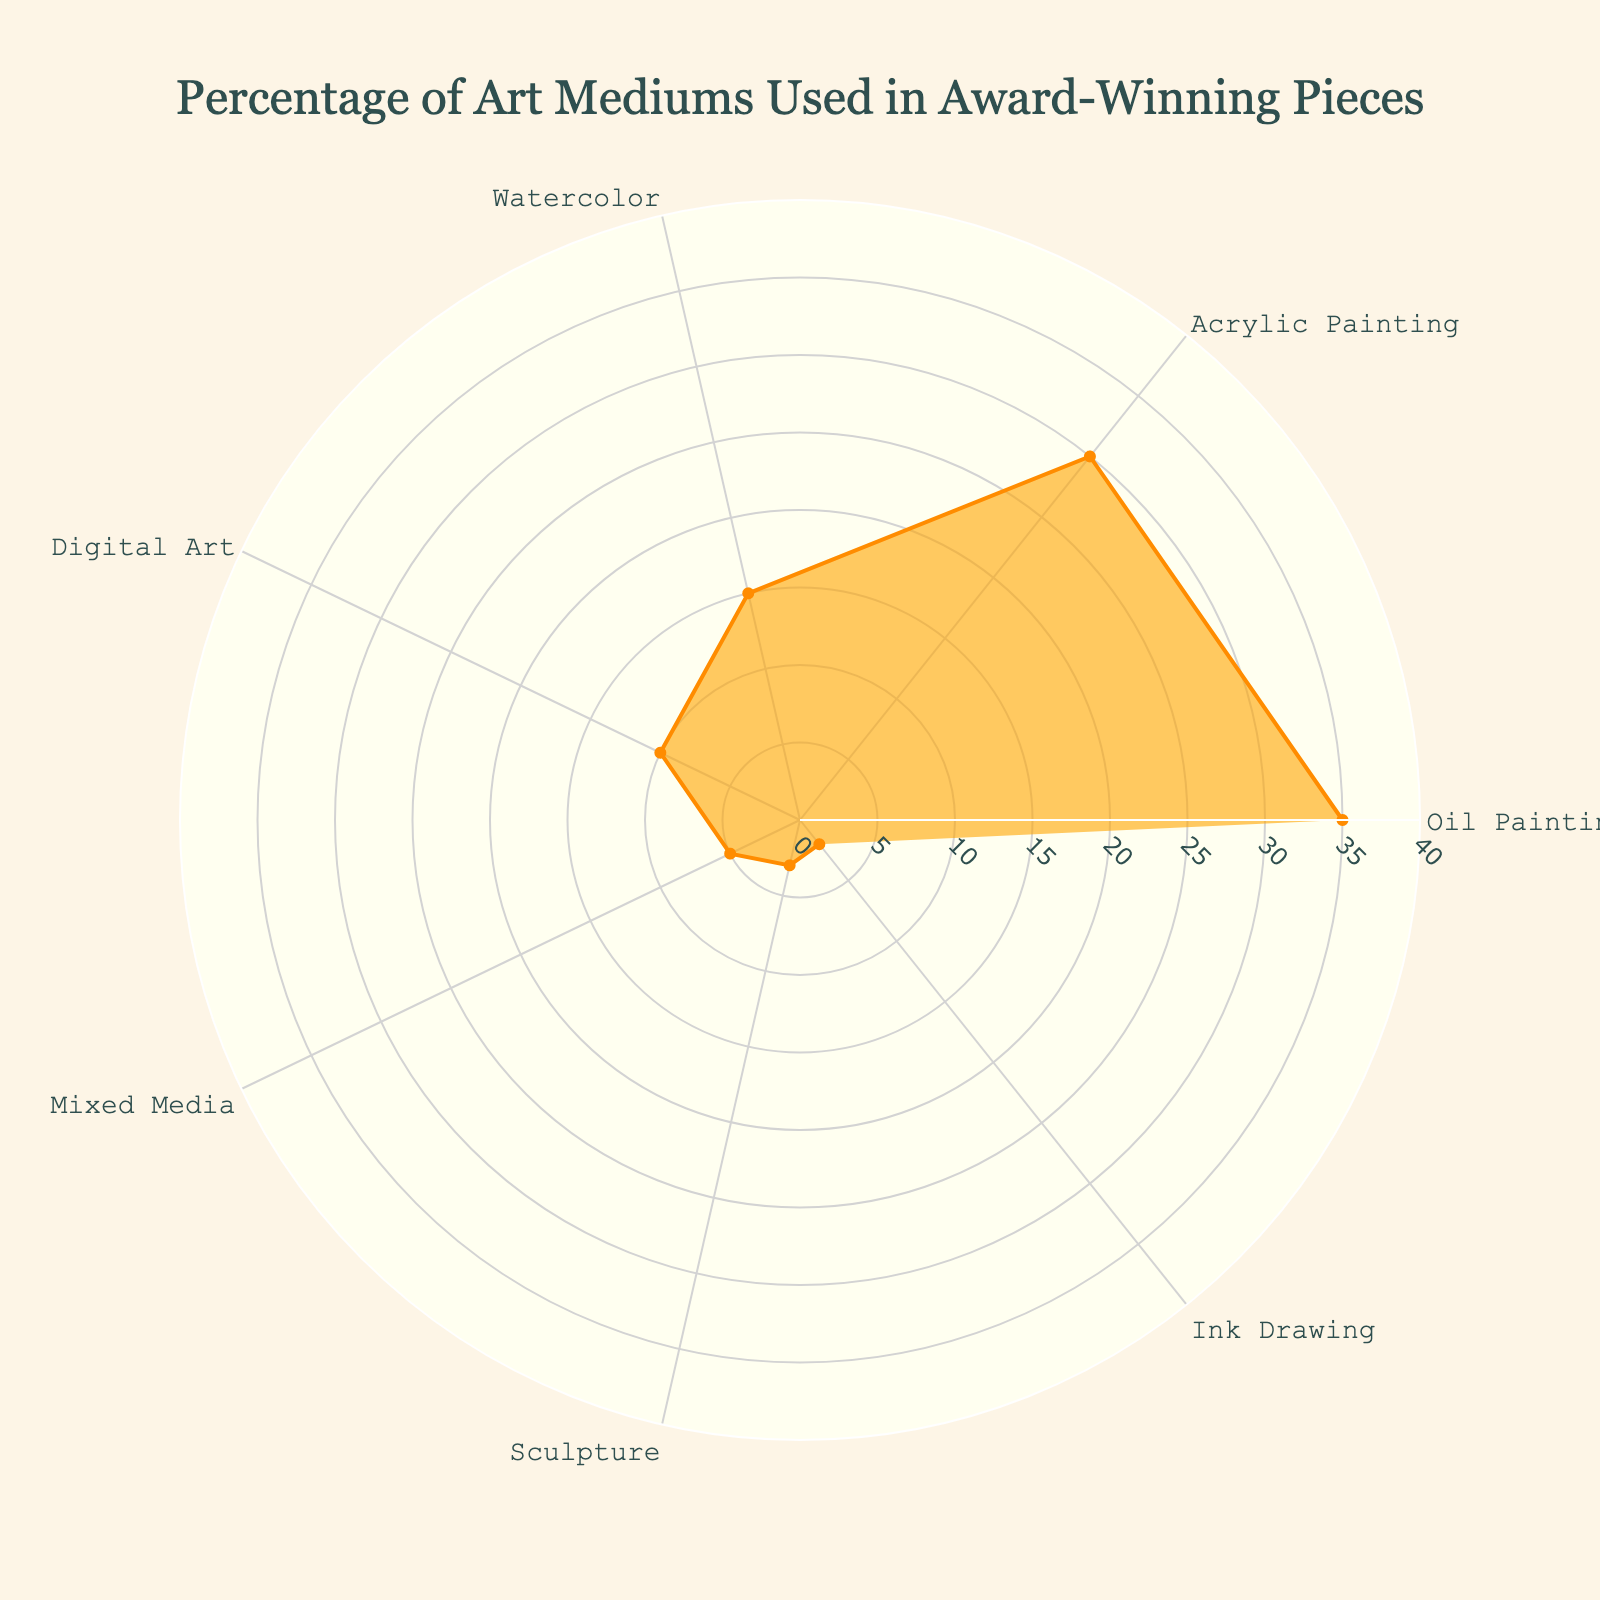What is the title of the chart? The title is displayed at the top of the chart. It reads, "Percentage of Art Mediums Used in Award-Winning Pieces".
Answer: "Percentage of Art Mediums Used in Award-Winning Pieces" Which art medium has the highest percentage in the chart? By looking at the radial values (r) and the labels (theta), the longest radial line indicates the highest percentage, which is 35%. This corresponds to "Oil Painting".
Answer: Oil Painting How many art mediums are displayed in the chart? Each segment of the chart represents an art medium. By counting the labels, we find there are 7 segments or art labels.
Answer: 7 Which medium has the smallest percentage, and what is that percentage? We look for the shortest radial distance from the center, which is 2%. This corresponds to "Ink Drawing".
Answer: Ink Drawing, 2% What is the combined percentage of "Acrylic Painting" and "Watercolor"? We find the percentages for "Acrylic Painting" (30%) and "Watercolor" (15%) and add them together: 30% + 15% = 45%.
Answer: 45% Which medium has a higher percentage, "Digital Art" or "Mixed Media", and by how much? "Digital Art" has a percentage of 10%, while "Mixed Media" has 5%. The difference is 10% - 5% = 5%.
Answer: Digital Art by 5% What is the average percentage of all art mediums displayed? We find the total percentage by summing all the values: 35% + 30% + 15% + 10% + 5% + 3% + 2% = 100%. Since there are 7 mediums, the average is 100% / 7 = approximately 14.29%.
Answer: 14.29% What range is used for the radial axis in the chart? The radial axis extends from 0 to a slightly higher value than the highest percentage. Since the highest percentage is 35%, the range is from 0 to 40.
Answer: 0 to 40 Which medium has a percentage three times higher than that of Sculpture? Sculpture has a percentage of 3%. Three times 3% is 9%. The closest higher percentage is "Digital Art" with 10%.
Answer: Digital Art Compare the percentage of "Oil Painting" to the combined percentage of "Mixed Media" and "Sculpture". Which is higher and by how much? "Oil Painting" is 35%. "Mixed Media" is 5% and "Sculpture" is 3%, adding up to 5% + 3% = 8%. The difference is 35% - 8% = 27%.
Answer: Oil Painting by 27% 